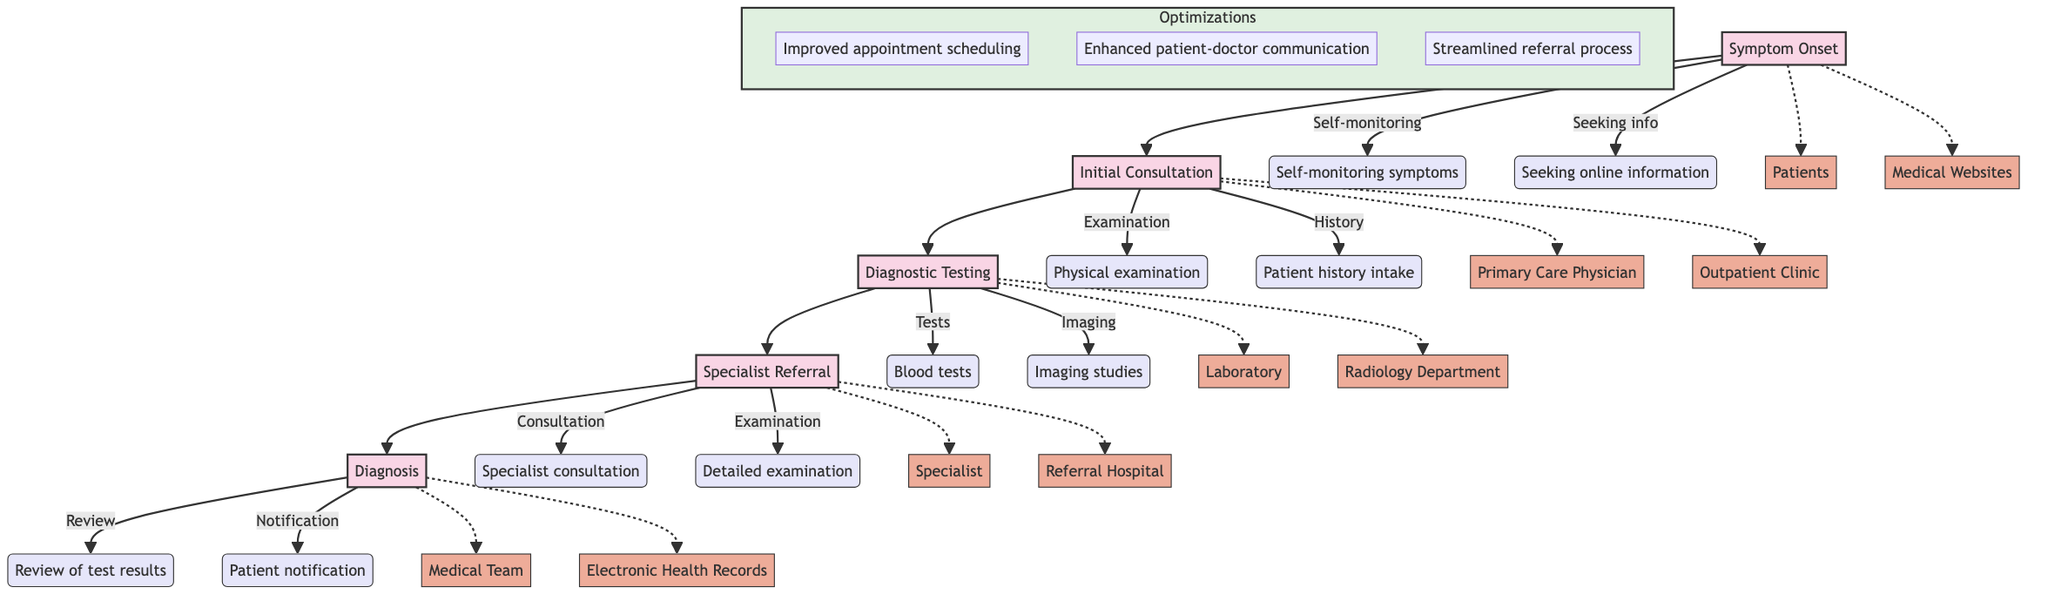What is the first stage in the patient diagnostic journey? The first stage mentioned in the diagram is "Symptom Onset." This is the starting point of the process before any consultations or testing occurs.
Answer: Symptom Onset How many stages are present in the diagnostic journey? The diagram lists five distinct stages: Symptom Onset, Initial Consultation, Diagnostic Testing, Specialist Referral, and Diagnosis. By counting these stages, we find there are a total of five.
Answer: 5 What action occurs during the Initial Consultation? During the Initial Consultation stage, specific actions such as "Physical examination" and "Patient history intake" are carried out. These actions are directly linked to the second stage.
Answer: Physical examination Which entity interacts with the patient during Diagnostic Testing? The entity responsible for interacting with the patient during the Diagnostic Testing stage is the "Laboratory" as tests such as blood tests and imaging studies are conducted there.
Answer: Laboratory What is the last action performed in the diagnostic journey? The last action performed in the diagnostic journey is "Patient notification," where the patient is informed of the final diagnosis. This action is part of the final stage, Diagnosis.
Answer: Patient notification Which stage has patient self-monitoring as an action? The action of "Self-monitoring symptoms" is included in the first stage, which is "Symptom Onset." This indicates that patients begin to take responsibility for observing their symptoms from the start.
Answer: Symptom Onset How does the Specialist Referral stage connect to the Diagnosis stage? The connection between the Specialist Referral stage and the Diagnosis stage is a progression where the referral leads to further consultation and examination, ultimately resulting in a final diagnosis.
Answer: Through specialist consultation What optimization focuses on improving patient-doctor interaction? One of the optimizations listed in the diagram is "Enhanced patient-doctor communication.” This specifically targets the way patients and doctors interact during the diagnostic journey.
Answer: Enhanced patient-doctor communication 